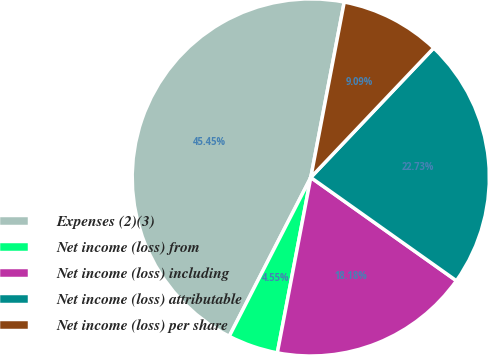Convert chart. <chart><loc_0><loc_0><loc_500><loc_500><pie_chart><fcel>Expenses (2)(3)<fcel>Net income (loss) from<fcel>Net income (loss) including<fcel>Net income (loss) attributable<fcel>Net income (loss) per share<nl><fcel>45.45%<fcel>4.55%<fcel>18.18%<fcel>22.73%<fcel>9.09%<nl></chart> 